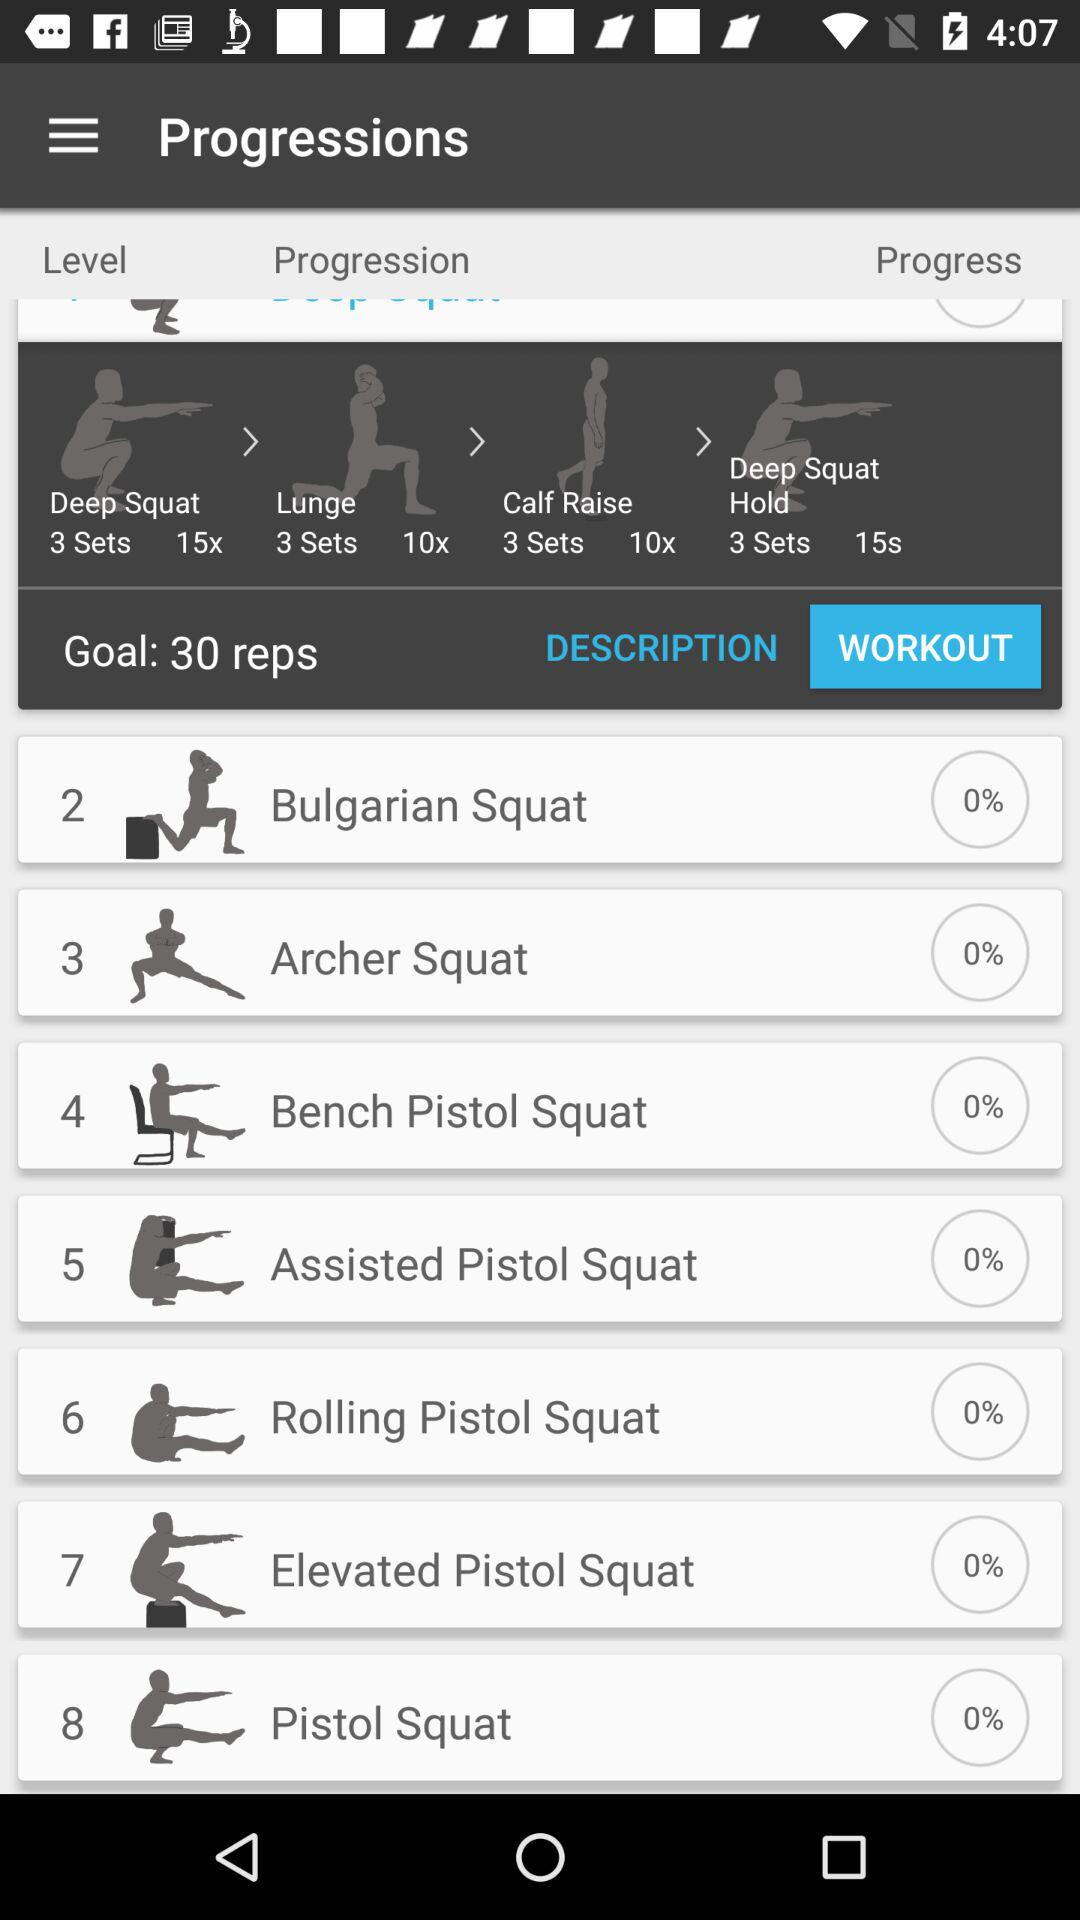How many exercises are there in the workout?
Answer the question using a single word or phrase. 8 